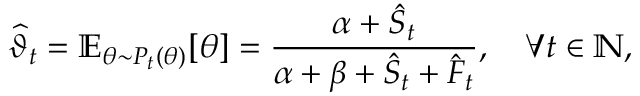<formula> <loc_0><loc_0><loc_500><loc_500>\widehat { \vartheta } _ { t } = \mathbb { E } _ { \theta \sim P _ { t } ( \theta ) } [ \theta ] = \frac { \alpha + \hat { S } _ { t } } { \alpha + \beta + \hat { S } _ { t } + \hat { F } _ { t } } , \quad \forall t \in \mathbb { N } ,</formula> 